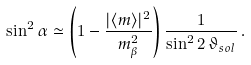<formula> <loc_0><loc_0><loc_500><loc_500>\sin ^ { 2 } \alpha \simeq \left ( 1 - \frac { | \langle m \rangle | ^ { 2 } } { m _ { \beta } ^ { 2 } } \right ) \frac { 1 } { \sin ^ { 2 } 2 \, \vartheta _ { s o l } } \, .</formula> 